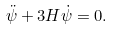<formula> <loc_0><loc_0><loc_500><loc_500>\ddot { \psi } + 3 H \dot { \psi } = 0 .</formula> 